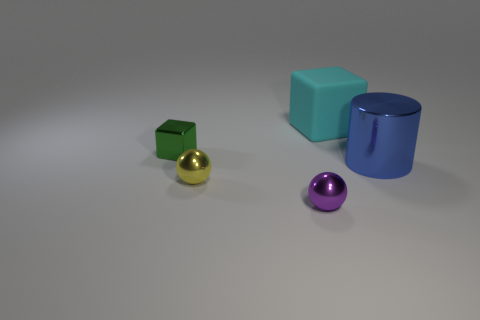Add 2 big rubber objects. How many objects exist? 7 Subtract all spheres. How many objects are left? 3 Add 2 yellow metal balls. How many yellow metal balls exist? 3 Subtract 0 cyan spheres. How many objects are left? 5 Subtract all small rubber cylinders. Subtract all yellow balls. How many objects are left? 4 Add 2 matte objects. How many matte objects are left? 3 